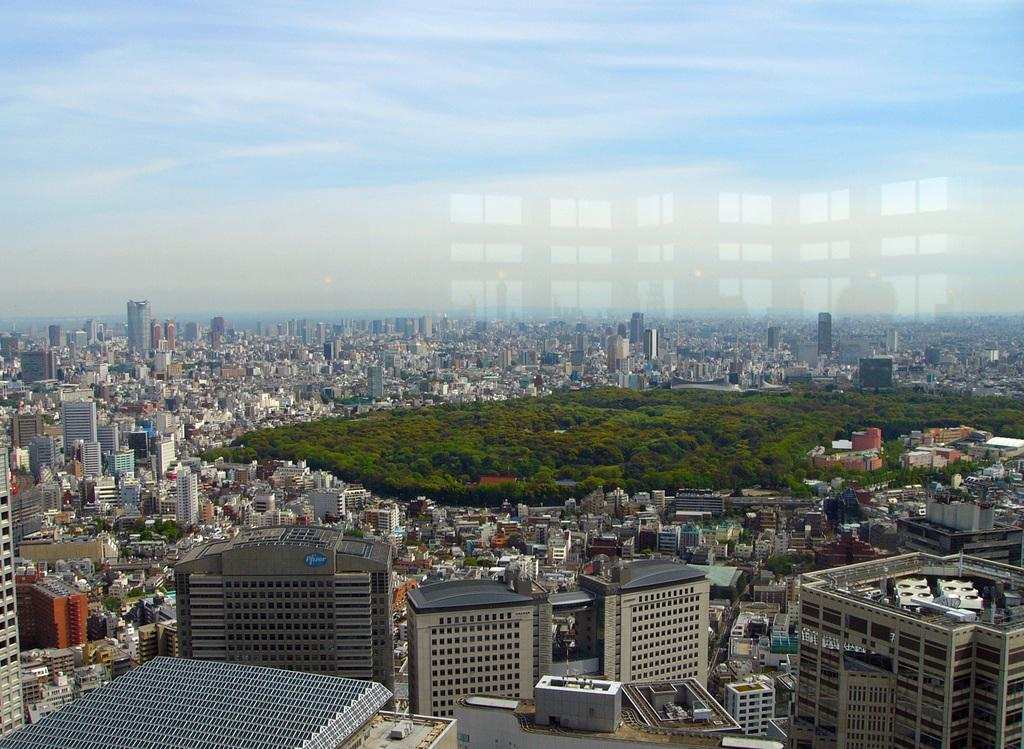What is located in the center of the image? There are buildings, a wall, trees, and plants in the center of the image. Can you describe the background of the image? The sky is visible in the background of the image, and there are clouds present. What type of vegetation can be seen in the image? Trees and plants are visible in the image. Can you see a robin perched on the wall in the image? There is no robin present in the image; it only features buildings, a wall, trees, plants, and the sky with clouds. 